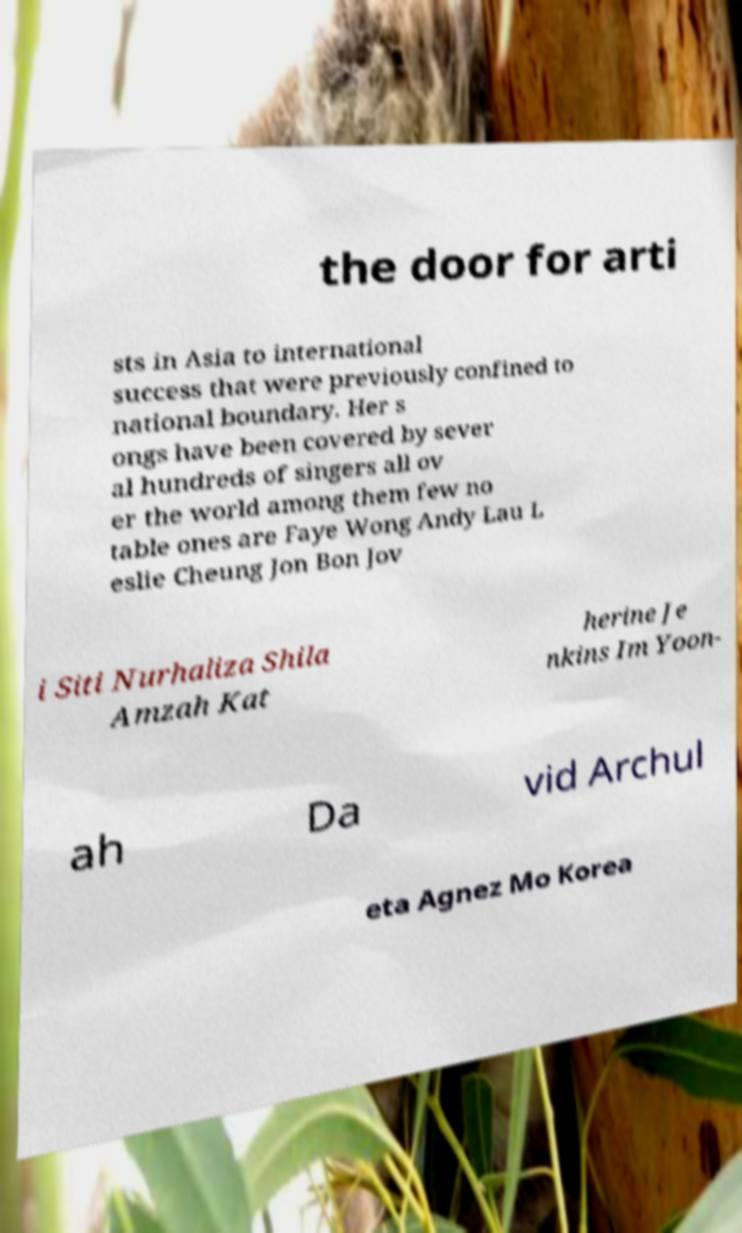For documentation purposes, I need the text within this image transcribed. Could you provide that? the door for arti sts in Asia to international success that were previously confined to national boundary. Her s ongs have been covered by sever al hundreds of singers all ov er the world among them few no table ones are Faye Wong Andy Lau L eslie Cheung Jon Bon Jov i Siti Nurhaliza Shila Amzah Kat herine Je nkins Im Yoon- ah Da vid Archul eta Agnez Mo Korea 